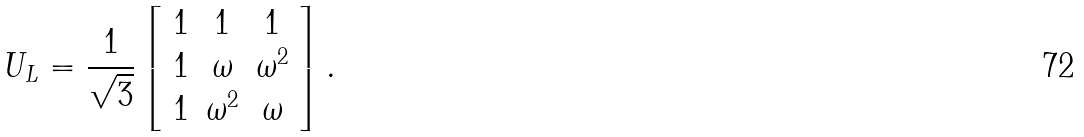<formula> <loc_0><loc_0><loc_500><loc_500>U _ { L } = { \frac { 1 } { \sqrt { 3 } } } \left [ \begin{array} { c c c } { 1 } & { 1 } & { 1 } \\ { 1 } & { \omega } & { { \omega ^ { 2 } } } \\ { 1 } & { { \omega ^ { 2 } } } & { \omega } \end{array} \right ] .</formula> 